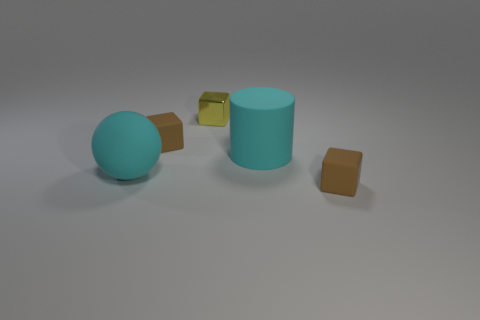Add 3 metallic cubes. How many metallic cubes exist? 4 Add 5 cylinders. How many objects exist? 10 Subtract all brown cubes. How many cubes are left? 1 Subtract all brown rubber blocks. How many blocks are left? 1 Subtract 1 cyan spheres. How many objects are left? 4 Subtract all cylinders. How many objects are left? 4 Subtract 1 cylinders. How many cylinders are left? 0 Subtract all green cylinders. Subtract all purple cubes. How many cylinders are left? 1 Subtract all red balls. How many brown cubes are left? 2 Subtract all large cyan rubber balls. Subtract all large things. How many objects are left? 2 